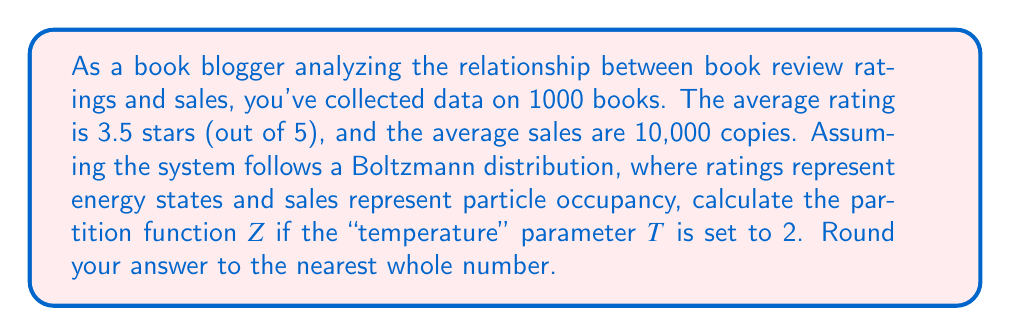Could you help me with this problem? To solve this problem, we'll use concepts from statistical thermodynamics:

1) In this analogy, book ratings are energy states (E), and sales represent occupancy (N).

2) The Boltzmann distribution is given by:

   $$N_i = N e^{-E_i/kT}$$

   where $N_i$ is the number of particles in state i, N is the total number of particles, $E_i$ is the energy of state i, k is Boltzmann's constant (which we'll assume is 1 for simplicity), and T is temperature.

3) The partition function Z is defined as:

   $$Z = \sum_{i} e^{-E_i/kT}$$

4) In our case, we have 5 energy states (1 to 5 stars). We need to calculate $e^{-E_i/kT}$ for each state:

   For 1 star: $e^{-1/2} = 0.6065$
   For 2 stars: $e^{-2/2} = 0.3679$
   For 3 stars: $e^{-3/2} = 0.2231$
   For 4 stars: $e^{-4/2} = 0.1353$
   For 5 stars: $e^{-5/2} = 0.0821$

5) The partition function Z is the sum of these values:

   $$Z = 0.6065 + 0.3679 + 0.2231 + 0.1353 + 0.0821 = 1.4149$$

6) Rounding to the nearest whole number gives us 1.
Answer: 1 